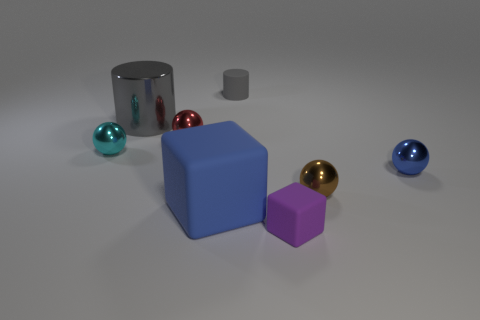Add 1 blue objects. How many objects exist? 9 Subtract all cubes. How many objects are left? 6 Subtract 0 brown cylinders. How many objects are left? 8 Subtract all small brown spheres. Subtract all tiny cyan metal balls. How many objects are left? 6 Add 3 big blue matte cubes. How many big blue matte cubes are left? 4 Add 1 blue shiny spheres. How many blue shiny spheres exist? 2 